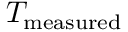Convert formula to latex. <formula><loc_0><loc_0><loc_500><loc_500>T _ { m e a s u r e d }</formula> 